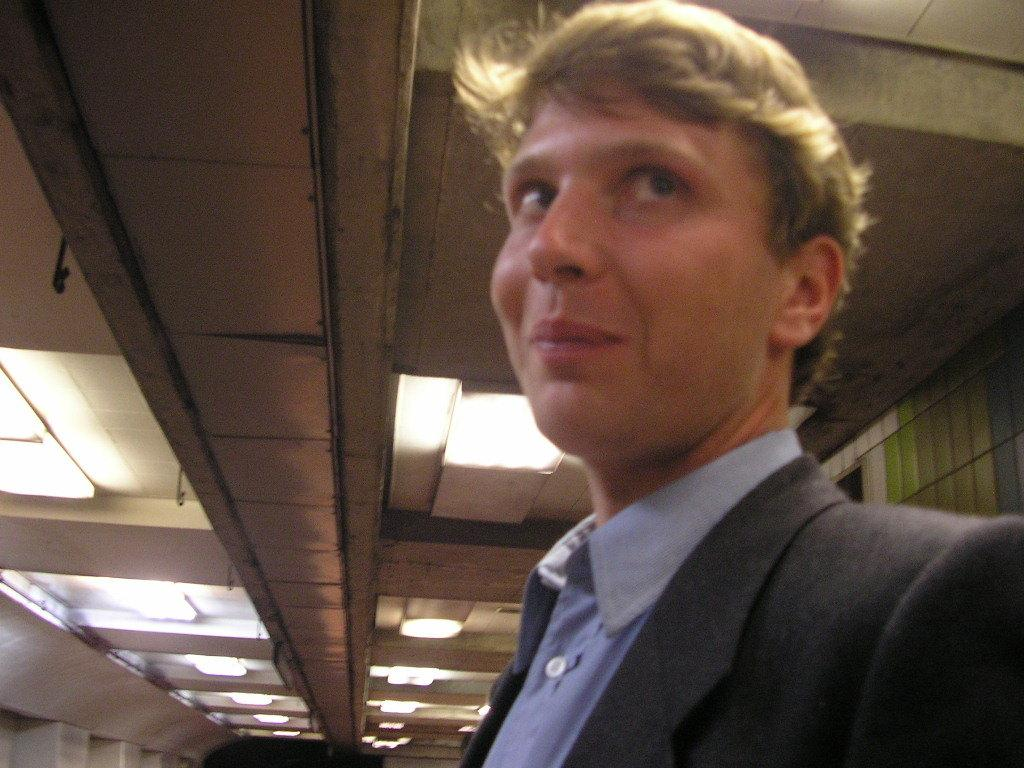What can be seen on the right side of the image? There is a person on the right side of the image. What feature is present on the roof in the image? There are lights attached to the roof in the image. Is the person being punished for their actions in the image? There is no indication in the image that the person is being punished for any actions. 